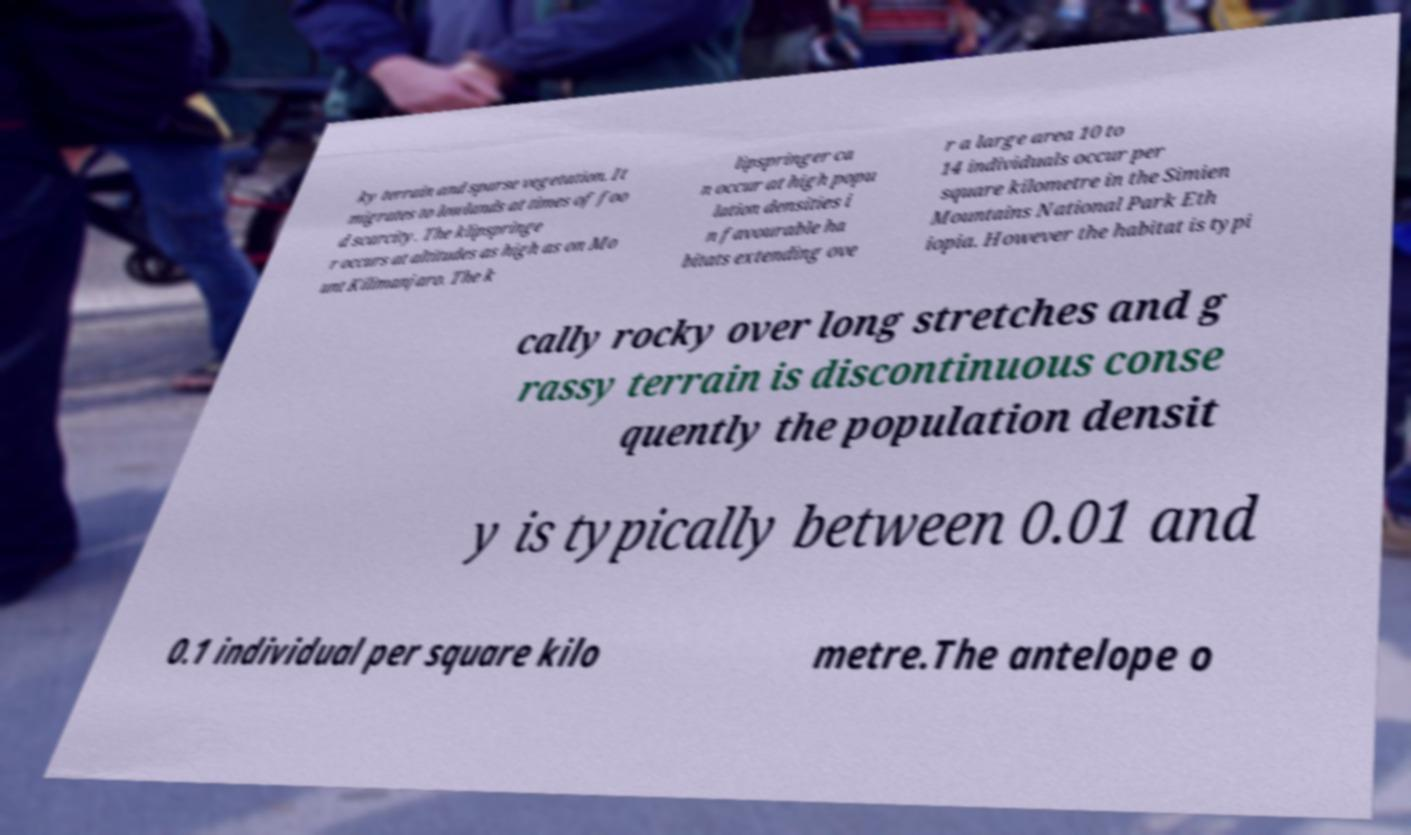For documentation purposes, I need the text within this image transcribed. Could you provide that? ky terrain and sparse vegetation. It migrates to lowlands at times of foo d scarcity. The klipspringe r occurs at altitudes as high as on Mo unt Kilimanjaro. The k lipspringer ca n occur at high popu lation densities i n favourable ha bitats extending ove r a large area 10 to 14 individuals occur per square kilometre in the Simien Mountains National Park Eth iopia. However the habitat is typi cally rocky over long stretches and g rassy terrain is discontinuous conse quently the population densit y is typically between 0.01 and 0.1 individual per square kilo metre.The antelope o 